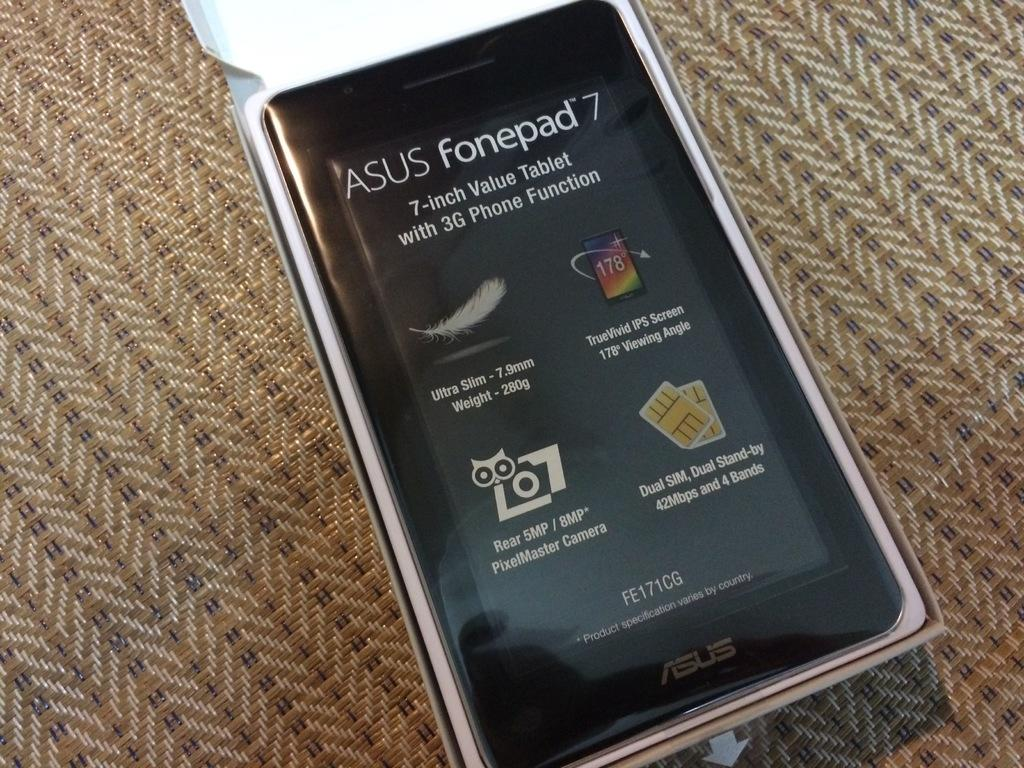What electronic device is visible in the image? There is a smartphone in the image. What information is displayed on the smartphone's screen? There are specifications mentioned on the smartphone's screen. How is the smartphone packaged in the image? The smartphone is placed in a white box. What is the color of the surface on which the smartphone is placed? The smartphone is placed on a brown surface. Can you see any monkeys playing with a plastic toy in the image? There are no monkeys or plastic toys present in the image. 